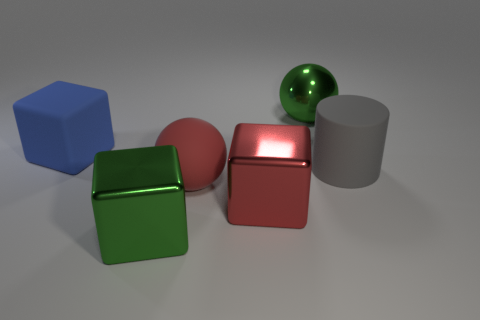Is the number of yellow shiny spheres less than the number of big gray rubber cylinders?
Your answer should be very brief. Yes. There is a large gray object; is it the same shape as the green metallic object that is behind the matte cube?
Keep it short and to the point. No. There is a metallic object that is on the left side of the red metal thing; does it have the same size as the red metallic object?
Your answer should be compact. Yes. What is the shape of the gray object that is the same size as the red block?
Your answer should be very brief. Cylinder. Does the red matte object have the same shape as the big blue object?
Ensure brevity in your answer.  No. What number of large green objects are the same shape as the red metal thing?
Give a very brief answer. 1. What number of rubber spheres are on the right side of the blue cube?
Provide a succinct answer. 1. Do the big metallic object that is to the left of the large red matte object and the big matte sphere have the same color?
Make the answer very short. No. What number of shiny balls are the same size as the gray thing?
Offer a very short reply. 1. The big blue thing that is the same material as the large gray object is what shape?
Offer a terse response. Cube. 